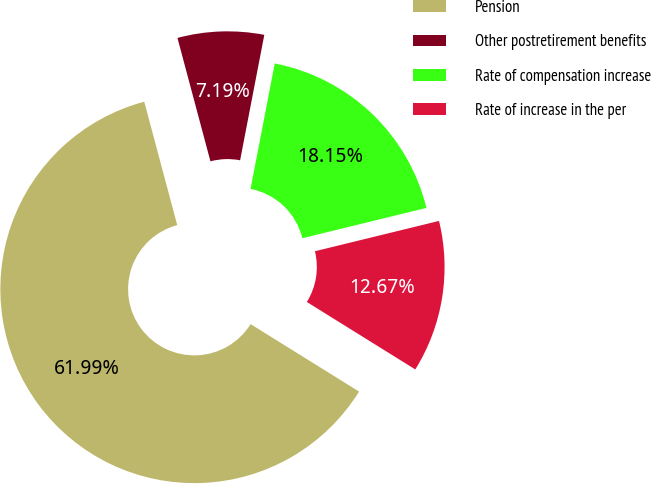<chart> <loc_0><loc_0><loc_500><loc_500><pie_chart><fcel>Pension<fcel>Other postretirement benefits<fcel>Rate of compensation increase<fcel>Rate of increase in the per<nl><fcel>61.98%<fcel>7.19%<fcel>18.15%<fcel>12.67%<nl></chart> 